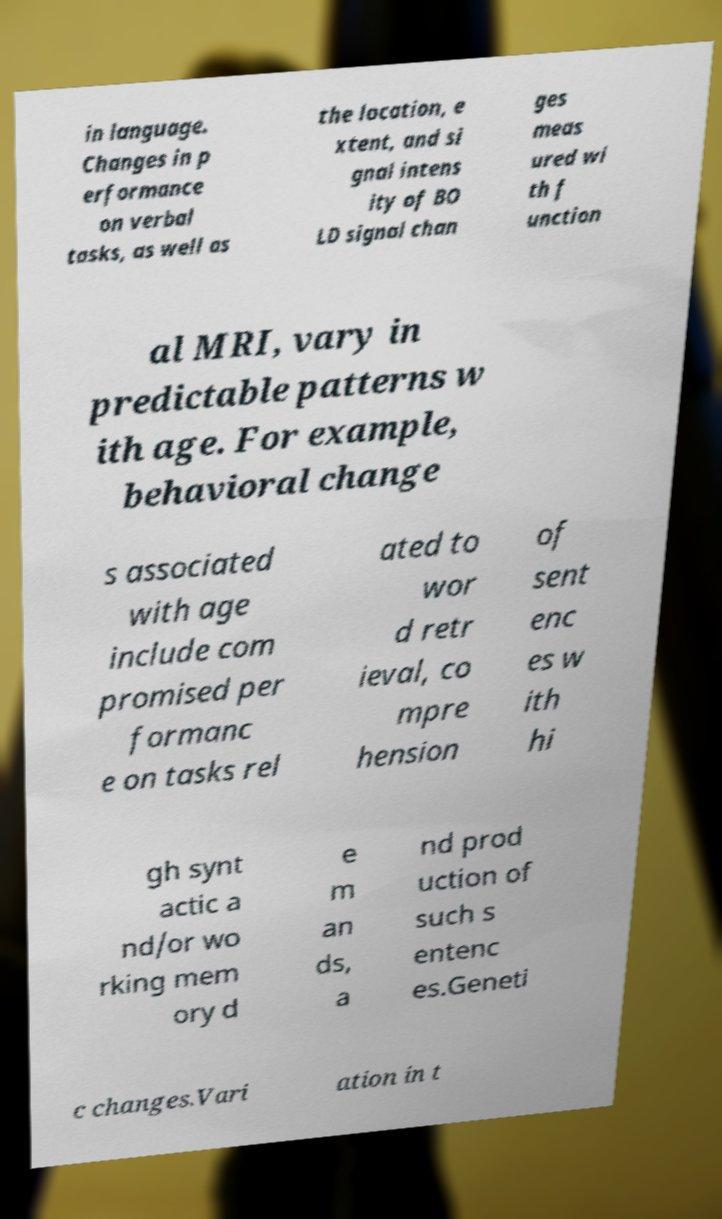What messages or text are displayed in this image? I need them in a readable, typed format. in language. Changes in p erformance on verbal tasks, as well as the location, e xtent, and si gnal intens ity of BO LD signal chan ges meas ured wi th f unction al MRI, vary in predictable patterns w ith age. For example, behavioral change s associated with age include com promised per formanc e on tasks rel ated to wor d retr ieval, co mpre hension of sent enc es w ith hi gh synt actic a nd/or wo rking mem ory d e m an ds, a nd prod uction of such s entenc es.Geneti c changes.Vari ation in t 